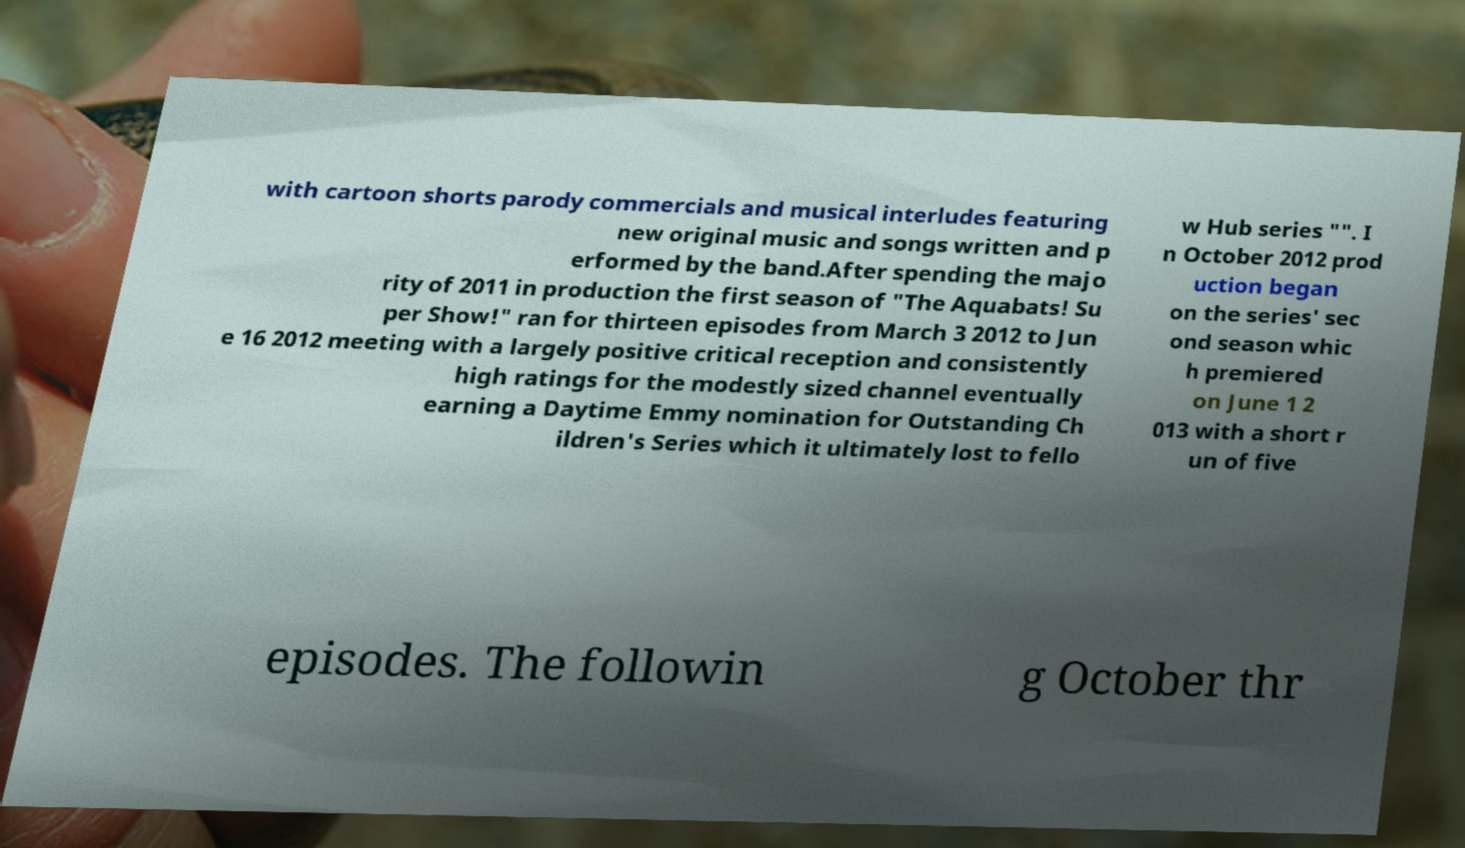Please read and relay the text visible in this image. What does it say? with cartoon shorts parody commercials and musical interludes featuring new original music and songs written and p erformed by the band.After spending the majo rity of 2011 in production the first season of "The Aquabats! Su per Show!" ran for thirteen episodes from March 3 2012 to Jun e 16 2012 meeting with a largely positive critical reception and consistently high ratings for the modestly sized channel eventually earning a Daytime Emmy nomination for Outstanding Ch ildren's Series which it ultimately lost to fello w Hub series "". I n October 2012 prod uction began on the series' sec ond season whic h premiered on June 1 2 013 with a short r un of five episodes. The followin g October thr 